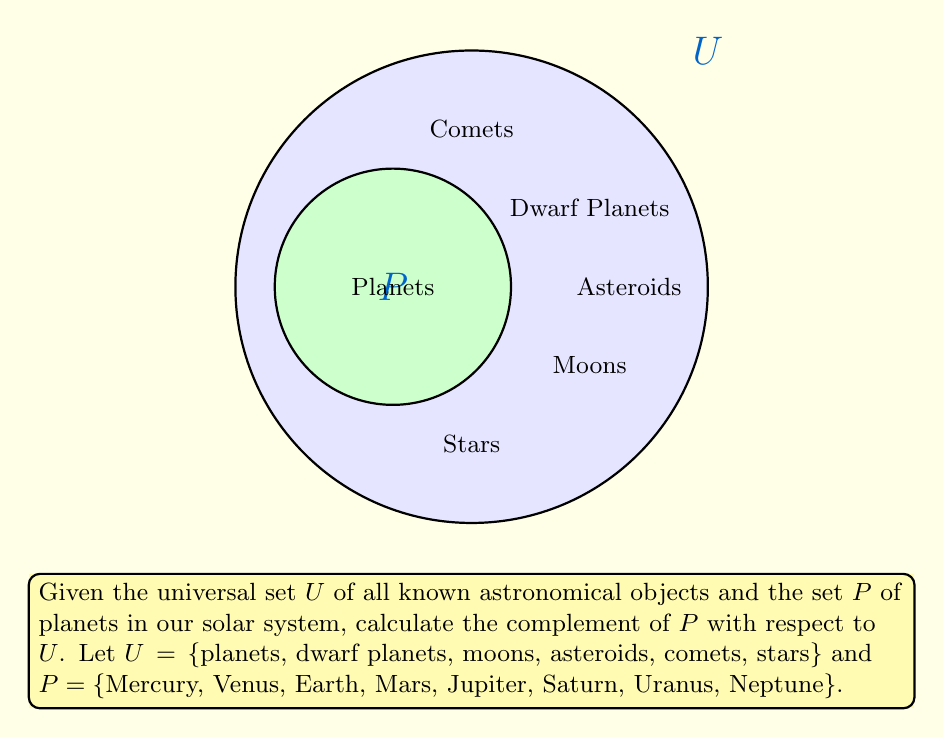Teach me how to tackle this problem. To calculate the complement of set $P$ with respect to the universal set $U$, we need to find all elements in $U$ that are not in $P$. This is denoted as $U \setminus P$ or $P^c$.

Step 1: Identify the elements in $U$ that are not in $P$.
- Dwarf planets (e.g., Pluto, Ceres)
- Moons (e.g., Earth's Moon, Jupiter's Galilean moons)
- Asteroids (e.g., Vesta, Pallas)
- Comets (e.g., Halley's Comet, Hale-Bopp)
- Stars (e.g., Sun, Proxima Centauri)

Step 2: Express the complement set mathematically.
$$P^c = U \setminus P = \{\text{x} \in U : \text{x} \notin P\}$$

Step 3: Write out the complement set in set notation.
$$P^c = \{\text{dwarf planets, moons, asteroids, comets, stars}\}$$

This set includes all astronomical objects in the universal set $U$ except for the planets in our solar system.
Answer: $P^c = \{\text{dwarf planets, moons, asteroids, comets, stars}\}$ 